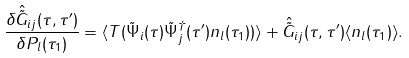<formula> <loc_0><loc_0><loc_500><loc_500>\frac { \delta \hat { \tilde { G } } _ { i j } ( \tau , \tau ^ { \prime } ) } { \delta P _ { l } ( \tau _ { 1 } ) } = \langle T ( \tilde { \Psi } _ { i } ( \tau ) \tilde { \Psi } ^ { \dagger } _ { j } ( \tau ^ { \prime } ) n _ { l } ( \tau _ { 1 } ) ) \rangle + \hat { \tilde { G } } _ { i j } ( \tau , \tau ^ { \prime } ) \langle n _ { l } ( \tau _ { 1 } ) \rangle .</formula> 